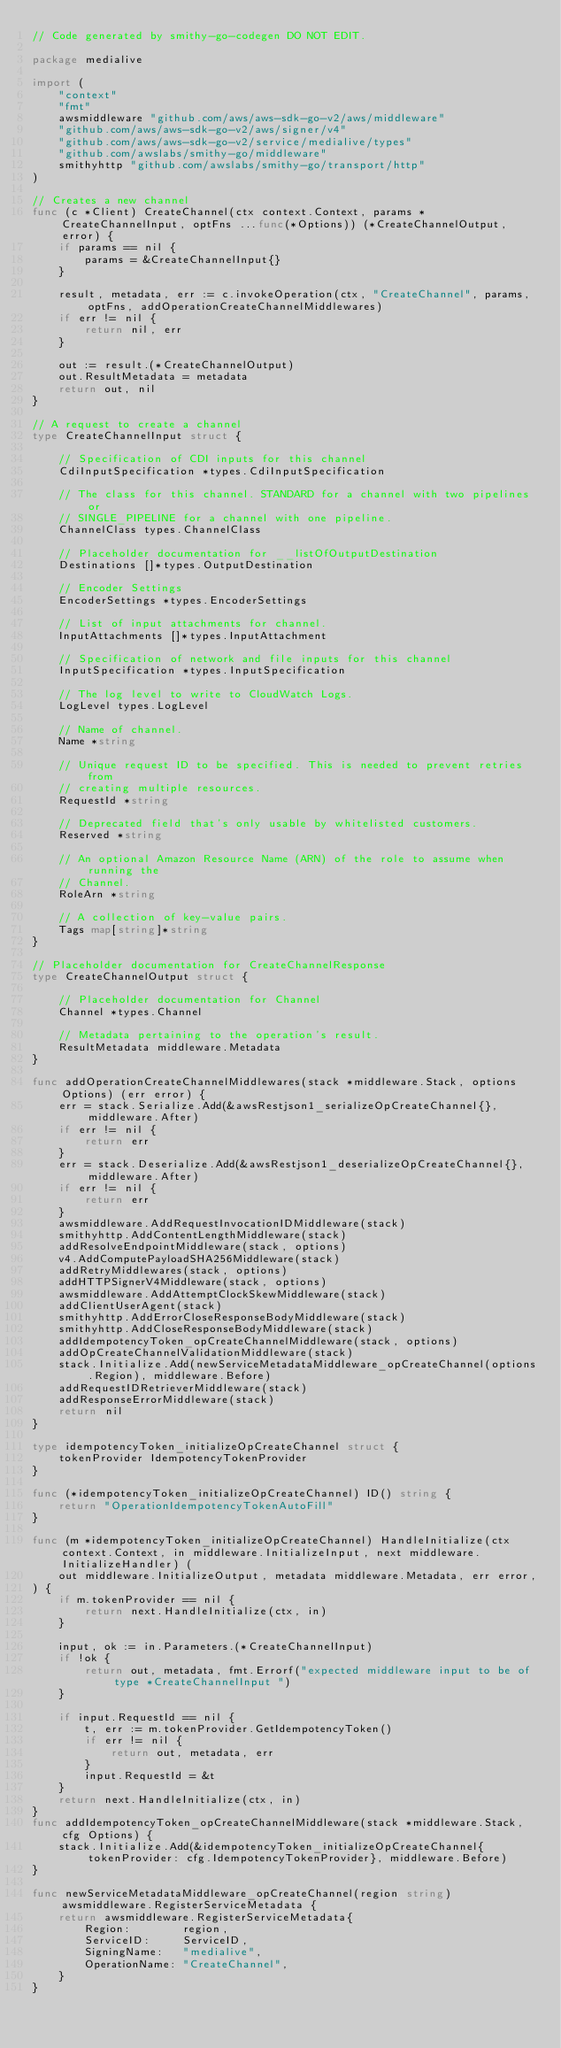Convert code to text. <code><loc_0><loc_0><loc_500><loc_500><_Go_>// Code generated by smithy-go-codegen DO NOT EDIT.

package medialive

import (
	"context"
	"fmt"
	awsmiddleware "github.com/aws/aws-sdk-go-v2/aws/middleware"
	"github.com/aws/aws-sdk-go-v2/aws/signer/v4"
	"github.com/aws/aws-sdk-go-v2/service/medialive/types"
	"github.com/awslabs/smithy-go/middleware"
	smithyhttp "github.com/awslabs/smithy-go/transport/http"
)

// Creates a new channel
func (c *Client) CreateChannel(ctx context.Context, params *CreateChannelInput, optFns ...func(*Options)) (*CreateChannelOutput, error) {
	if params == nil {
		params = &CreateChannelInput{}
	}

	result, metadata, err := c.invokeOperation(ctx, "CreateChannel", params, optFns, addOperationCreateChannelMiddlewares)
	if err != nil {
		return nil, err
	}

	out := result.(*CreateChannelOutput)
	out.ResultMetadata = metadata
	return out, nil
}

// A request to create a channel
type CreateChannelInput struct {

	// Specification of CDI inputs for this channel
	CdiInputSpecification *types.CdiInputSpecification

	// The class for this channel. STANDARD for a channel with two pipelines or
	// SINGLE_PIPELINE for a channel with one pipeline.
	ChannelClass types.ChannelClass

	// Placeholder documentation for __listOfOutputDestination
	Destinations []*types.OutputDestination

	// Encoder Settings
	EncoderSettings *types.EncoderSettings

	// List of input attachments for channel.
	InputAttachments []*types.InputAttachment

	// Specification of network and file inputs for this channel
	InputSpecification *types.InputSpecification

	// The log level to write to CloudWatch Logs.
	LogLevel types.LogLevel

	// Name of channel.
	Name *string

	// Unique request ID to be specified. This is needed to prevent retries from
	// creating multiple resources.
	RequestId *string

	// Deprecated field that's only usable by whitelisted customers.
	Reserved *string

	// An optional Amazon Resource Name (ARN) of the role to assume when running the
	// Channel.
	RoleArn *string

	// A collection of key-value pairs.
	Tags map[string]*string
}

// Placeholder documentation for CreateChannelResponse
type CreateChannelOutput struct {

	// Placeholder documentation for Channel
	Channel *types.Channel

	// Metadata pertaining to the operation's result.
	ResultMetadata middleware.Metadata
}

func addOperationCreateChannelMiddlewares(stack *middleware.Stack, options Options) (err error) {
	err = stack.Serialize.Add(&awsRestjson1_serializeOpCreateChannel{}, middleware.After)
	if err != nil {
		return err
	}
	err = stack.Deserialize.Add(&awsRestjson1_deserializeOpCreateChannel{}, middleware.After)
	if err != nil {
		return err
	}
	awsmiddleware.AddRequestInvocationIDMiddleware(stack)
	smithyhttp.AddContentLengthMiddleware(stack)
	addResolveEndpointMiddleware(stack, options)
	v4.AddComputePayloadSHA256Middleware(stack)
	addRetryMiddlewares(stack, options)
	addHTTPSignerV4Middleware(stack, options)
	awsmiddleware.AddAttemptClockSkewMiddleware(stack)
	addClientUserAgent(stack)
	smithyhttp.AddErrorCloseResponseBodyMiddleware(stack)
	smithyhttp.AddCloseResponseBodyMiddleware(stack)
	addIdempotencyToken_opCreateChannelMiddleware(stack, options)
	addOpCreateChannelValidationMiddleware(stack)
	stack.Initialize.Add(newServiceMetadataMiddleware_opCreateChannel(options.Region), middleware.Before)
	addRequestIDRetrieverMiddleware(stack)
	addResponseErrorMiddleware(stack)
	return nil
}

type idempotencyToken_initializeOpCreateChannel struct {
	tokenProvider IdempotencyTokenProvider
}

func (*idempotencyToken_initializeOpCreateChannel) ID() string {
	return "OperationIdempotencyTokenAutoFill"
}

func (m *idempotencyToken_initializeOpCreateChannel) HandleInitialize(ctx context.Context, in middleware.InitializeInput, next middleware.InitializeHandler) (
	out middleware.InitializeOutput, metadata middleware.Metadata, err error,
) {
	if m.tokenProvider == nil {
		return next.HandleInitialize(ctx, in)
	}

	input, ok := in.Parameters.(*CreateChannelInput)
	if !ok {
		return out, metadata, fmt.Errorf("expected middleware input to be of type *CreateChannelInput ")
	}

	if input.RequestId == nil {
		t, err := m.tokenProvider.GetIdempotencyToken()
		if err != nil {
			return out, metadata, err
		}
		input.RequestId = &t
	}
	return next.HandleInitialize(ctx, in)
}
func addIdempotencyToken_opCreateChannelMiddleware(stack *middleware.Stack, cfg Options) {
	stack.Initialize.Add(&idempotencyToken_initializeOpCreateChannel{tokenProvider: cfg.IdempotencyTokenProvider}, middleware.Before)
}

func newServiceMetadataMiddleware_opCreateChannel(region string) awsmiddleware.RegisterServiceMetadata {
	return awsmiddleware.RegisterServiceMetadata{
		Region:        region,
		ServiceID:     ServiceID,
		SigningName:   "medialive",
		OperationName: "CreateChannel",
	}
}
</code> 